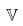<formula> <loc_0><loc_0><loc_500><loc_500>\mathbb { V }</formula> 